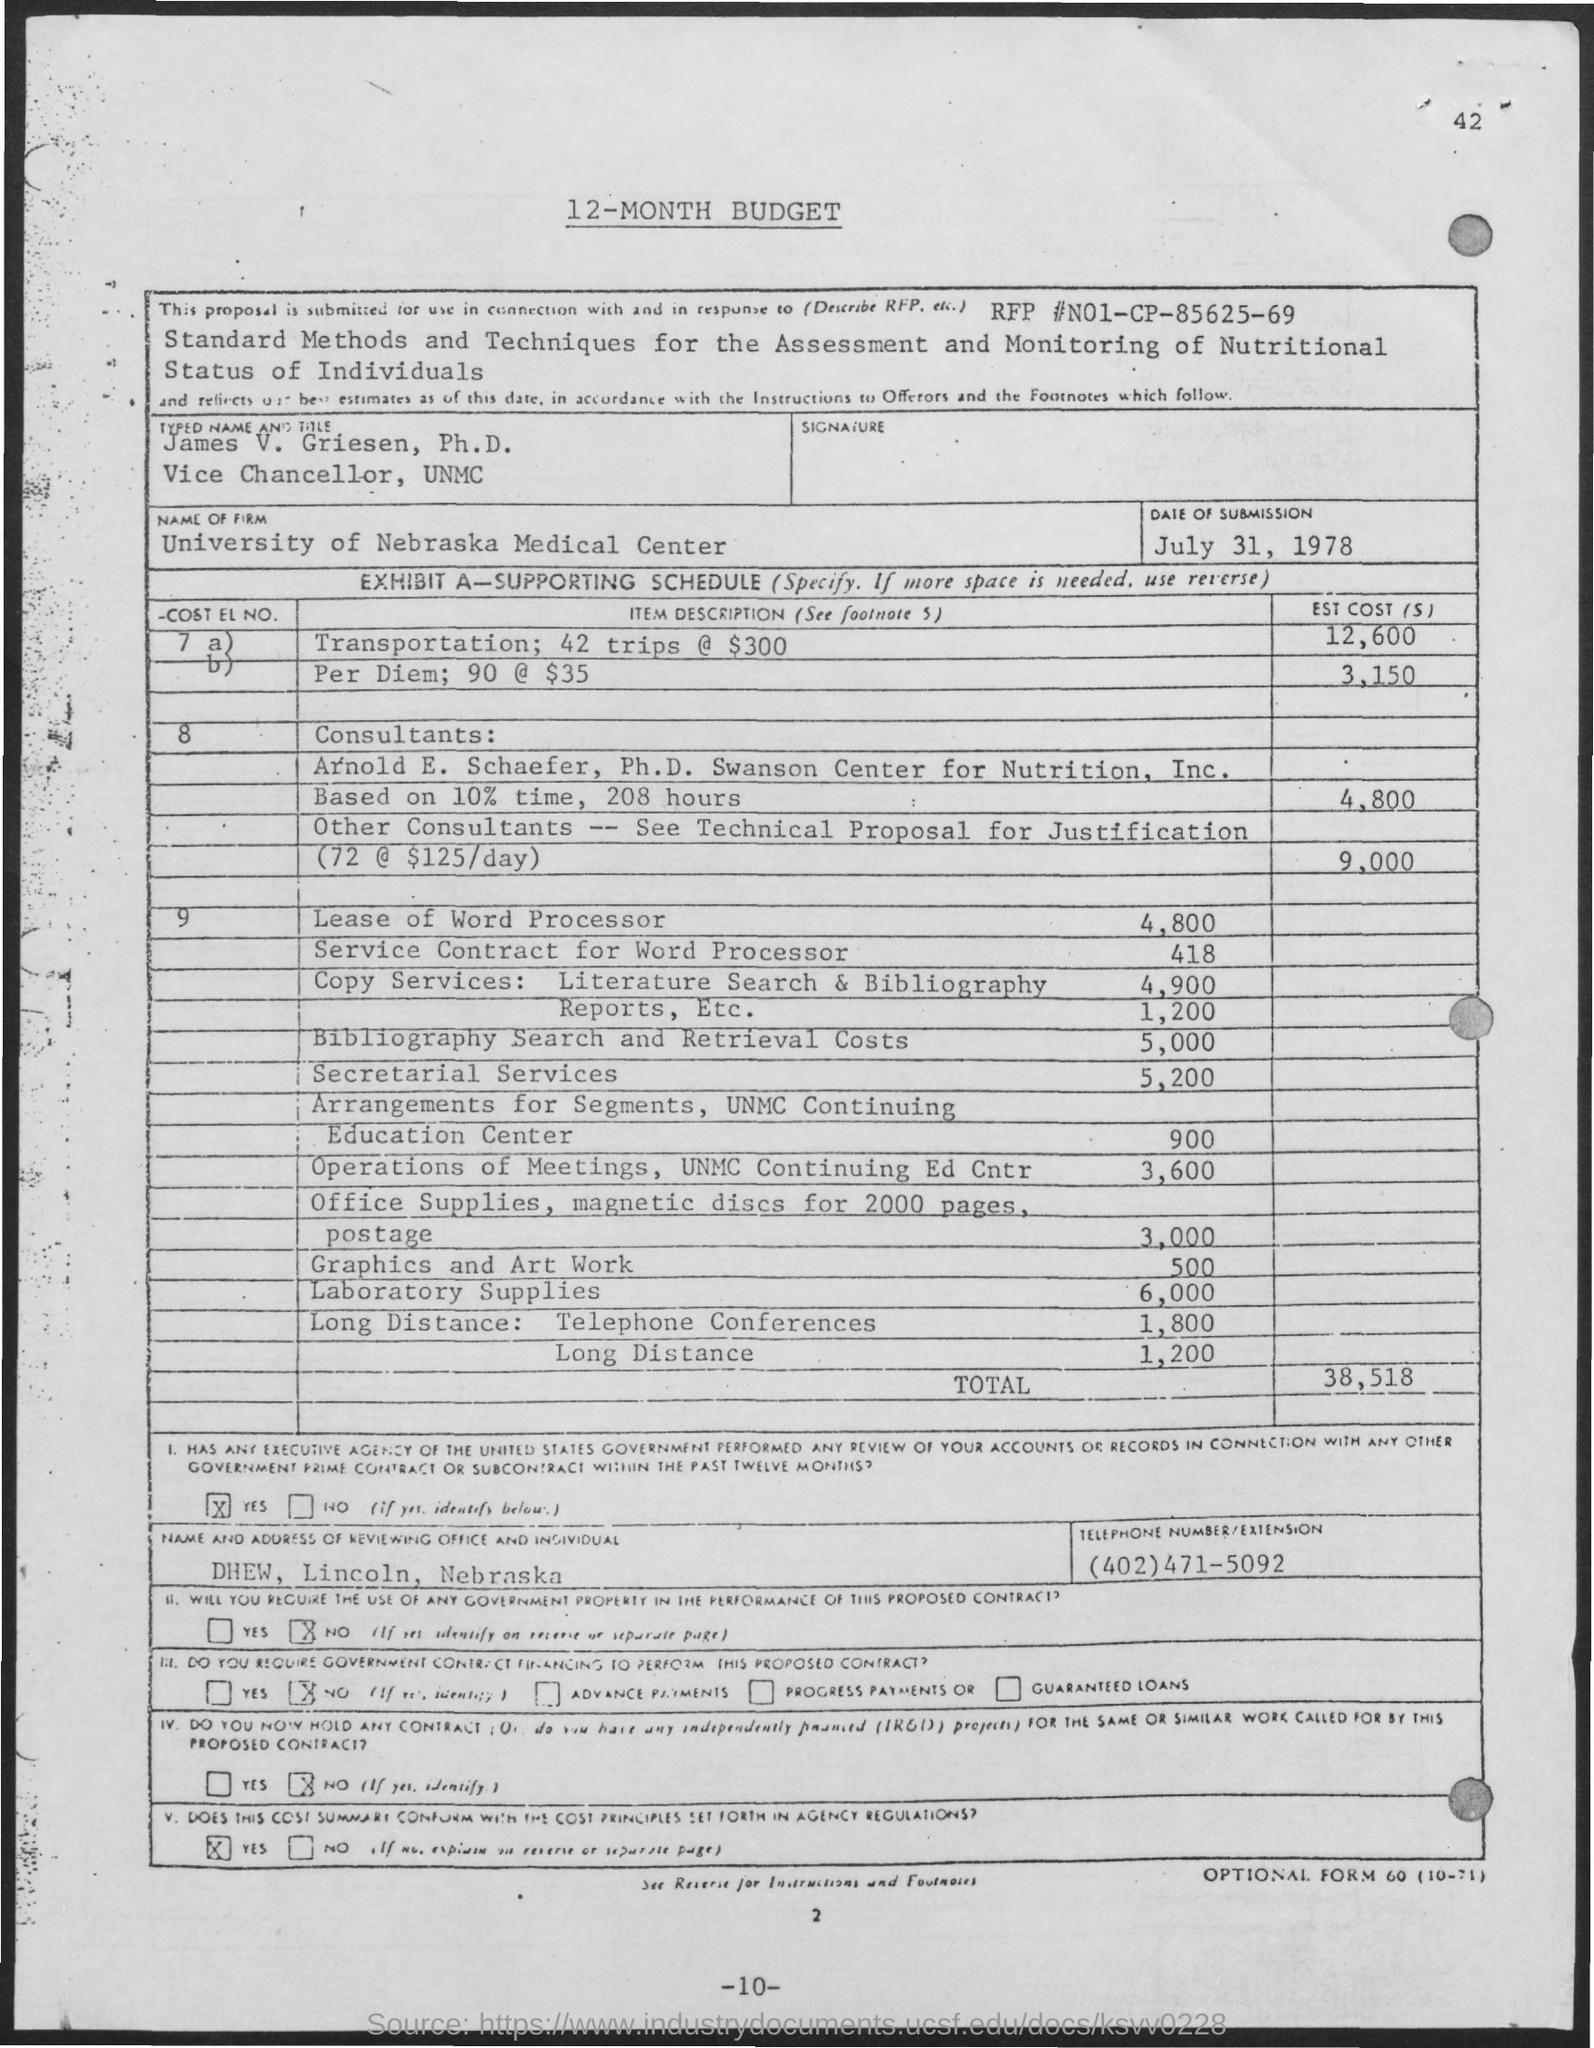Outline some significant characteristics in this image. The Vice Chancellor of UNMC is James V. Griesen. The University of Nebraska Medical Center is the name of the firm. 